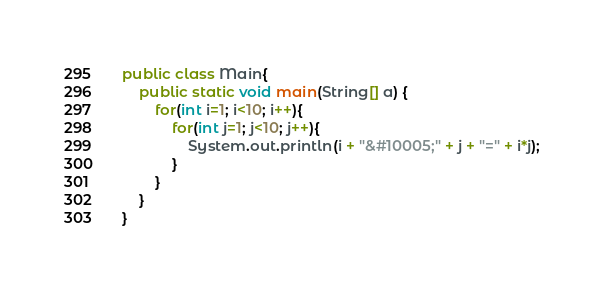Convert code to text. <code><loc_0><loc_0><loc_500><loc_500><_Java_>public class Main{
	public static void main(String[] a) {
		for(int i=1; i<10; i++){
			for(int j=1; j<10; j++){
				System.out.println(i + "&#10005;" + j + "=" + i*j);
			}
		}
	}
}</code> 